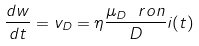<formula> <loc_0><loc_0><loc_500><loc_500>\frac { d w } { d t } = v _ { D } = \eta \frac { \mu _ { D } \ r o n } { D } i ( t )</formula> 